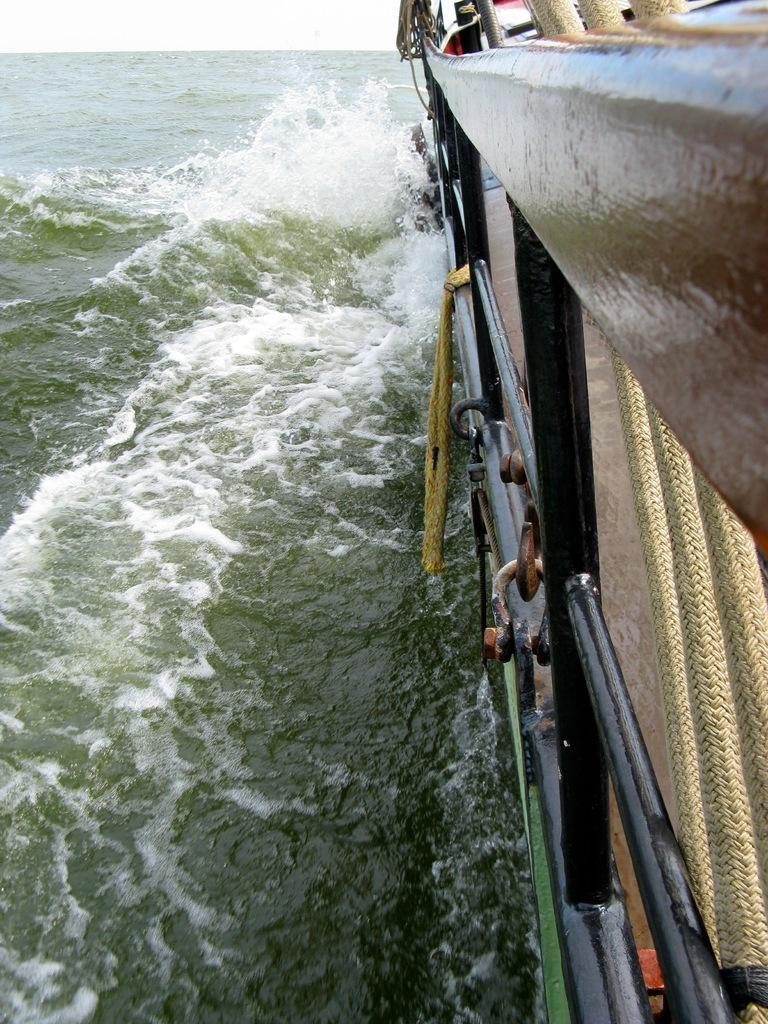What is the main subject of the image? The main subject of the image is a boat. Where is the boat located in the image? The boat is in the water. What else can be seen in the image besides the boat? The sky is visible in the image. How many squirrels are climbing the mast of the boat in the image? There are no squirrels present in the image, and the boat does not have a mast. What is the distance between the boat and the shore in the image? The provided facts do not give any information about the distance between the boat and the shore, so it cannot be determined from the image. 